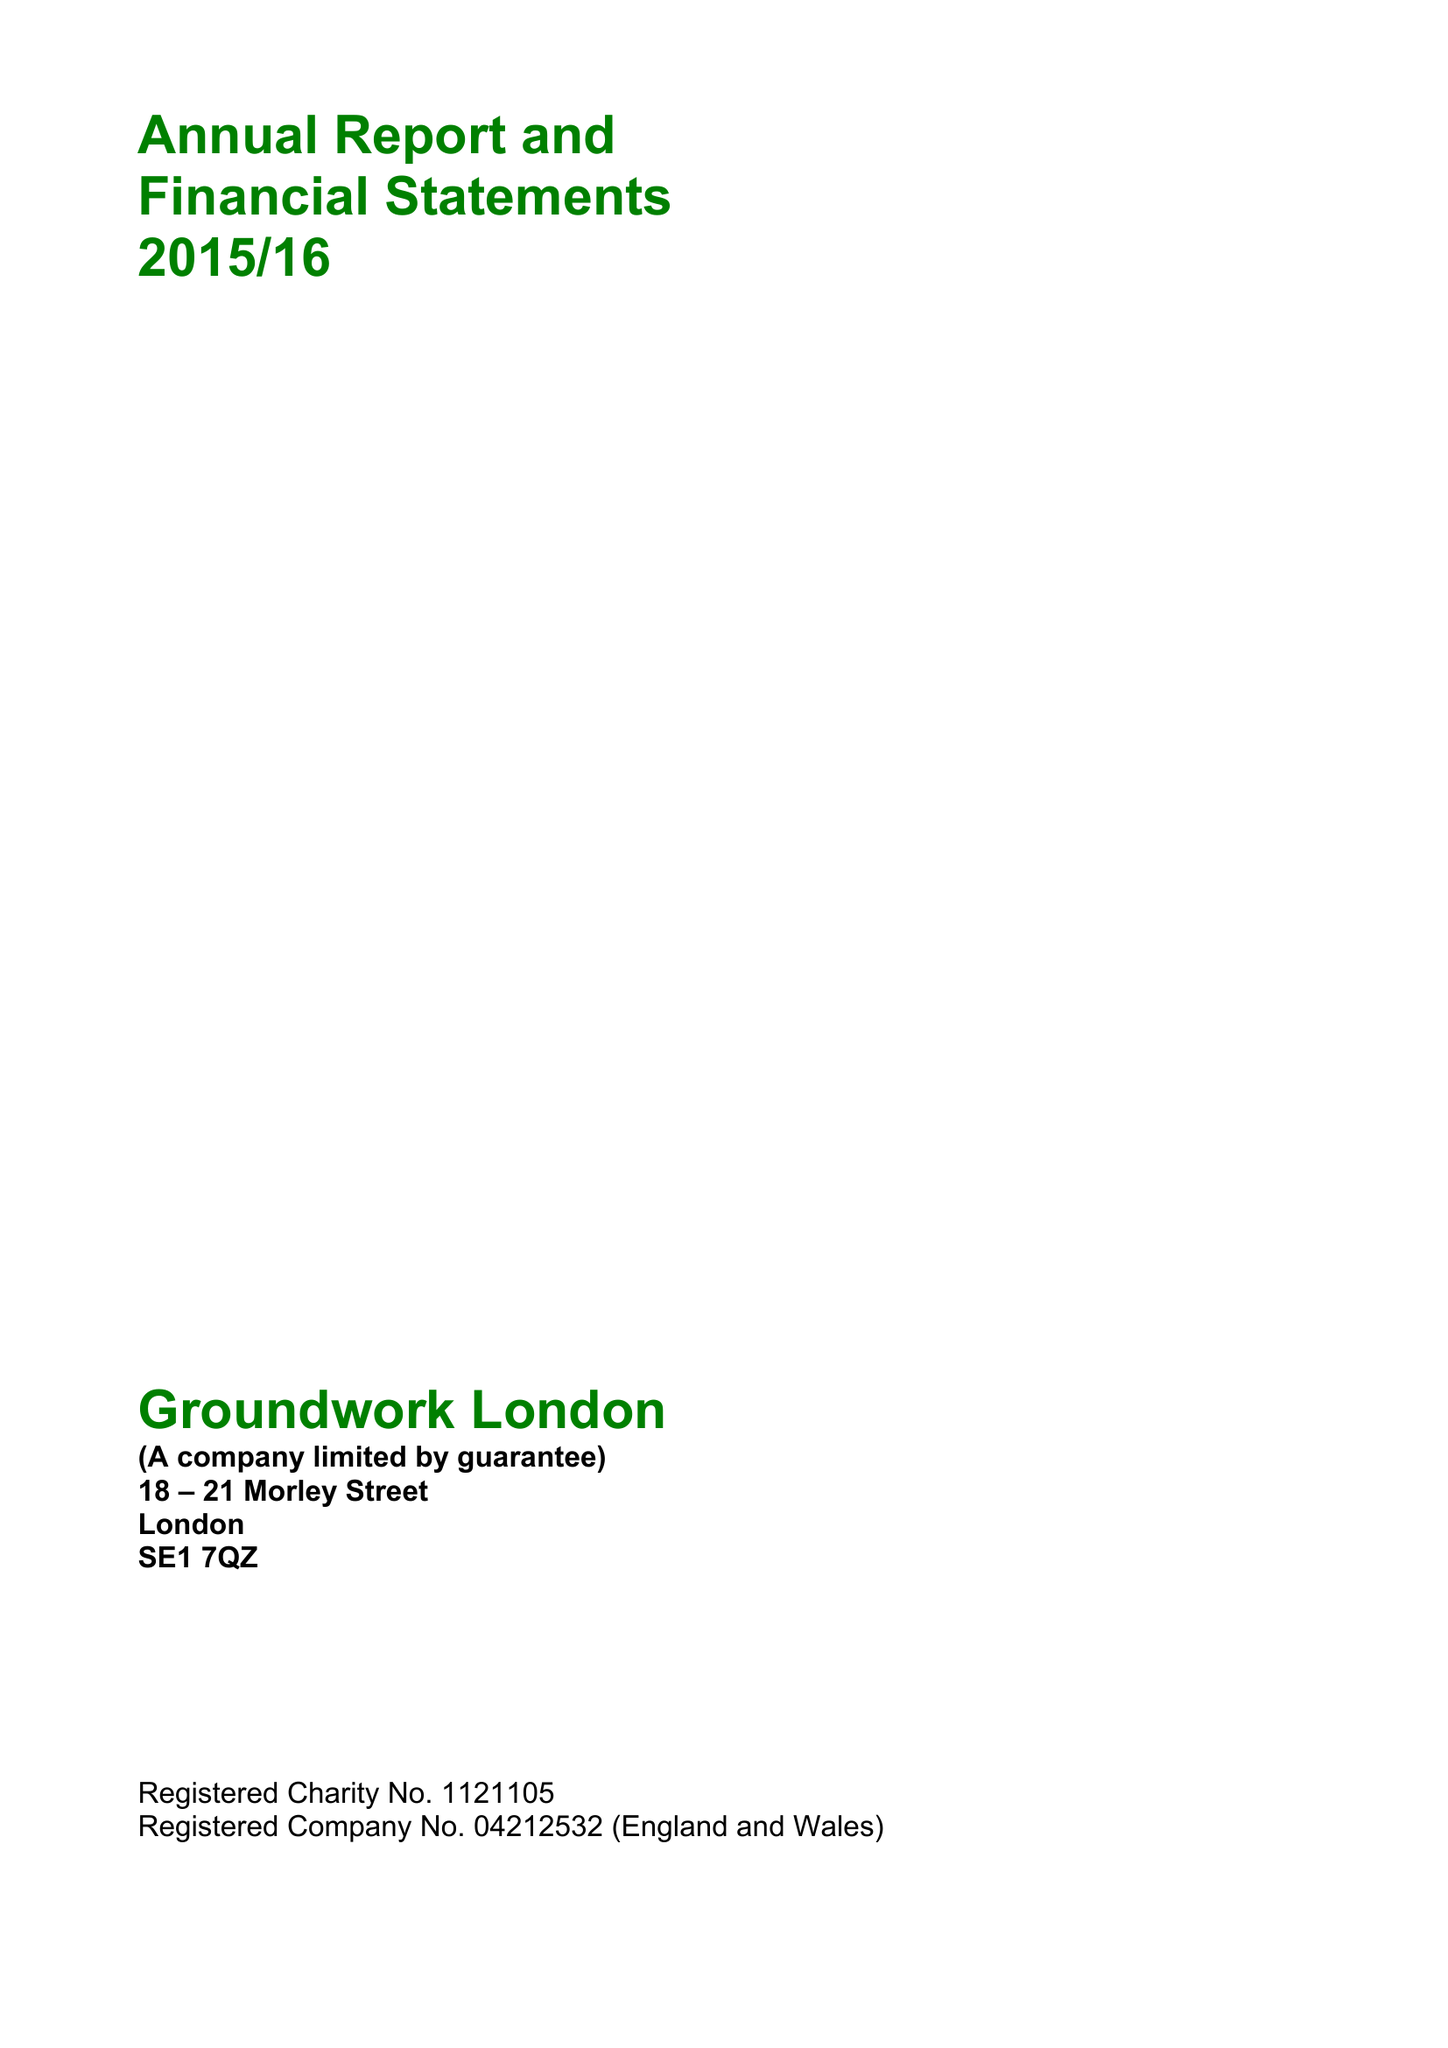What is the value for the address__postcode?
Answer the question using a single word or phrase. SE1 7QZ 